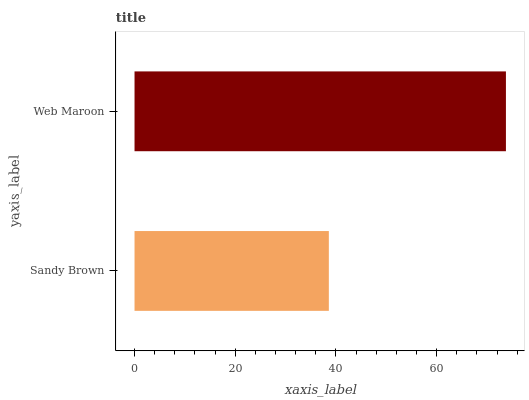Is Sandy Brown the minimum?
Answer yes or no. Yes. Is Web Maroon the maximum?
Answer yes or no. Yes. Is Web Maroon the minimum?
Answer yes or no. No. Is Web Maroon greater than Sandy Brown?
Answer yes or no. Yes. Is Sandy Brown less than Web Maroon?
Answer yes or no. Yes. Is Sandy Brown greater than Web Maroon?
Answer yes or no. No. Is Web Maroon less than Sandy Brown?
Answer yes or no. No. Is Web Maroon the high median?
Answer yes or no. Yes. Is Sandy Brown the low median?
Answer yes or no. Yes. Is Sandy Brown the high median?
Answer yes or no. No. Is Web Maroon the low median?
Answer yes or no. No. 